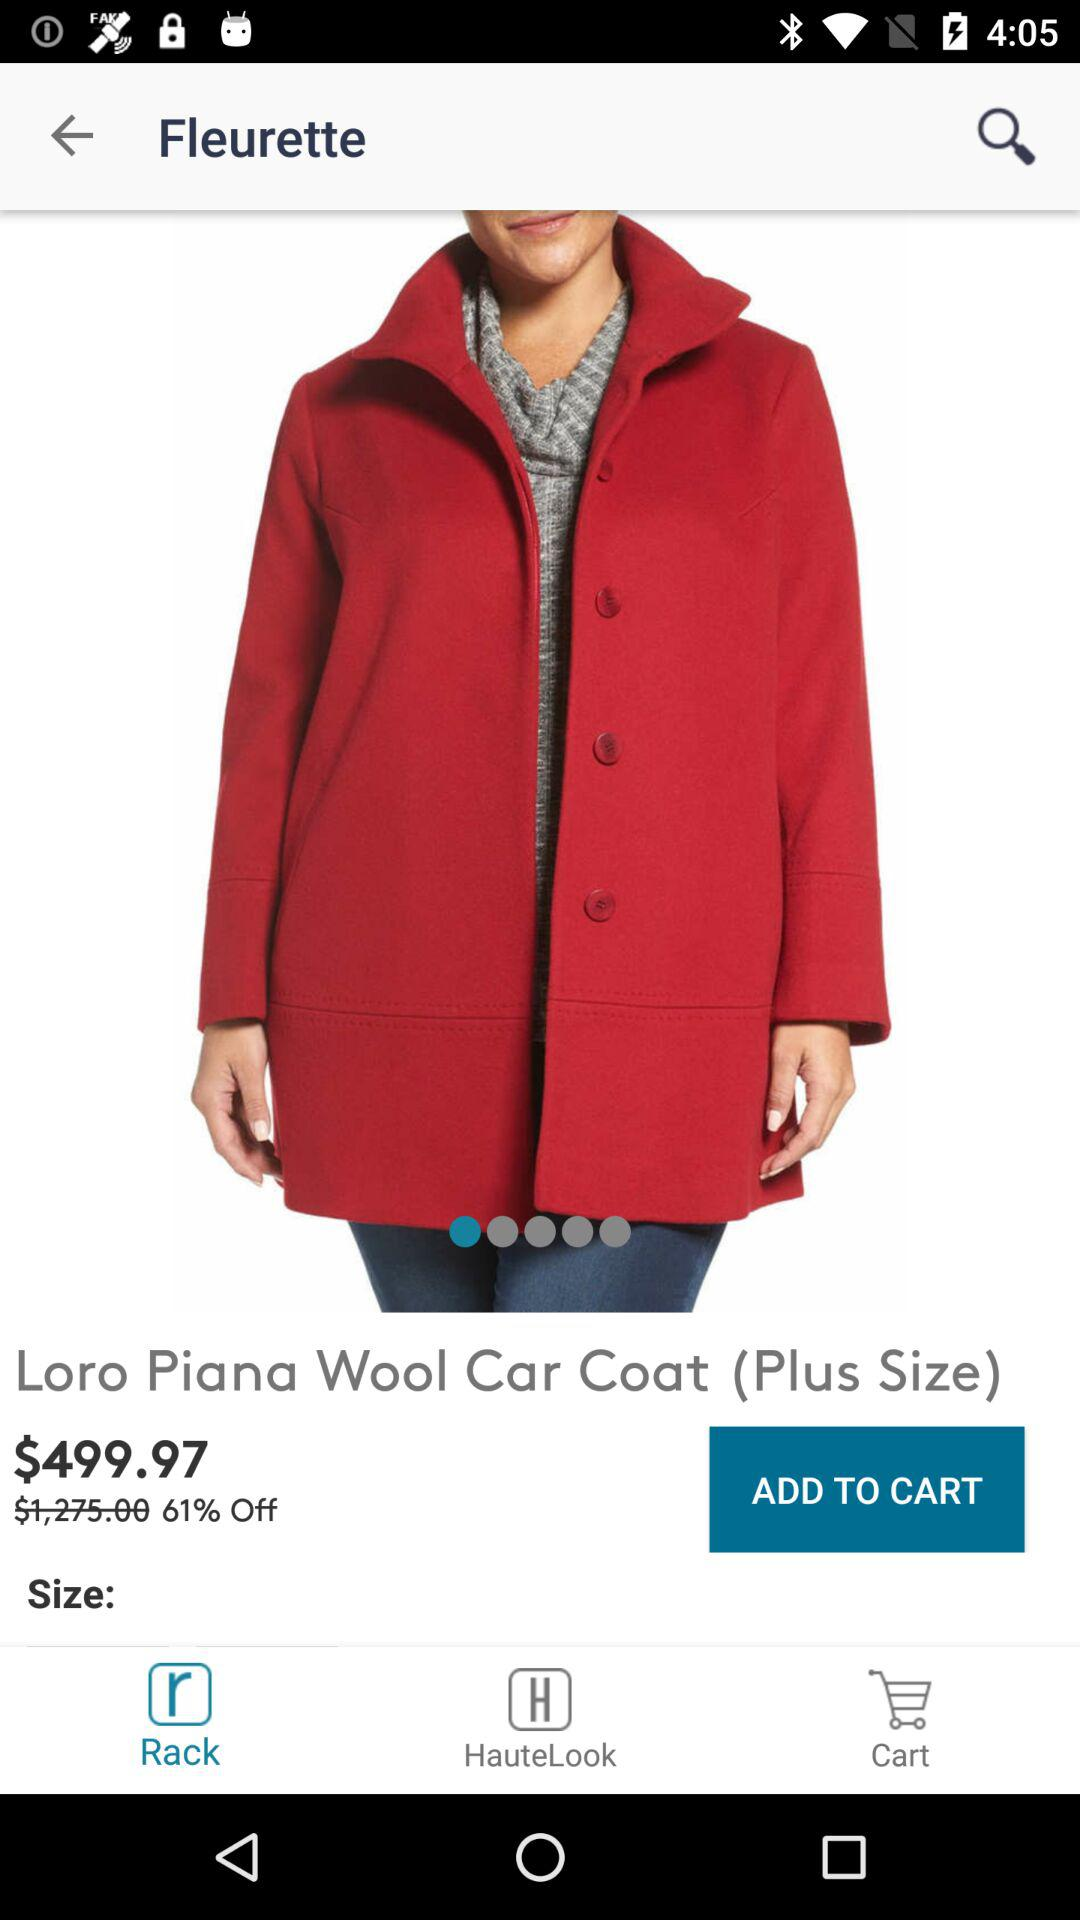What is the price of the product? The price of the product is $499.97. 